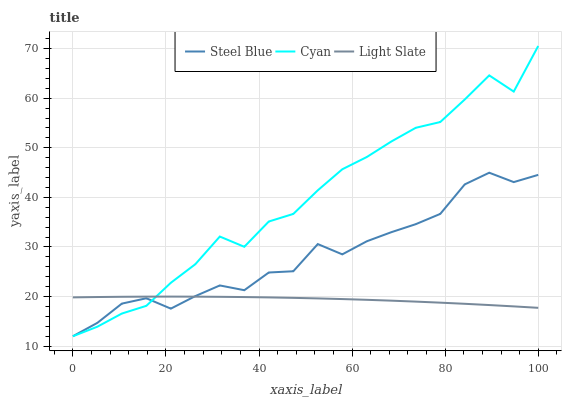Does Light Slate have the minimum area under the curve?
Answer yes or no. Yes. Does Cyan have the maximum area under the curve?
Answer yes or no. Yes. Does Steel Blue have the minimum area under the curve?
Answer yes or no. No. Does Steel Blue have the maximum area under the curve?
Answer yes or no. No. Is Light Slate the smoothest?
Answer yes or no. Yes. Is Cyan the roughest?
Answer yes or no. Yes. Is Steel Blue the smoothest?
Answer yes or no. No. Is Steel Blue the roughest?
Answer yes or no. No. Does Cyan have the lowest value?
Answer yes or no. Yes. Does Cyan have the highest value?
Answer yes or no. Yes. Does Steel Blue have the highest value?
Answer yes or no. No. Does Cyan intersect Steel Blue?
Answer yes or no. Yes. Is Cyan less than Steel Blue?
Answer yes or no. No. Is Cyan greater than Steel Blue?
Answer yes or no. No. 